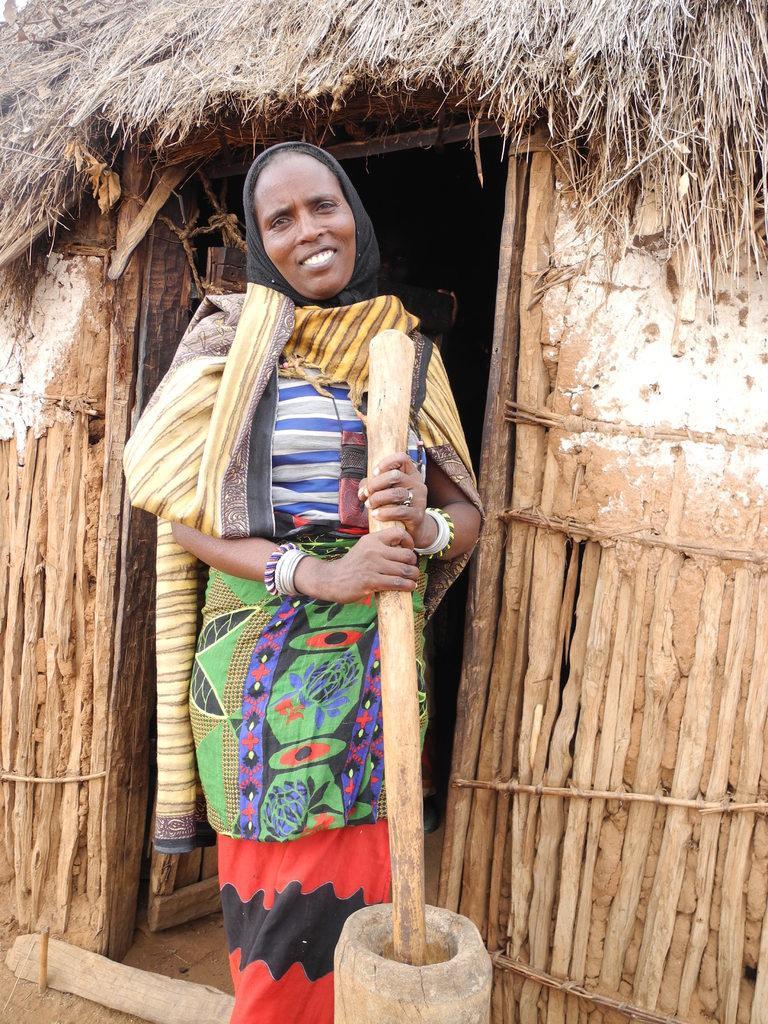Could you give a brief overview of what you see in this image? In this image we can see a lady and holding an object in her hand. There is a hut in the image. 